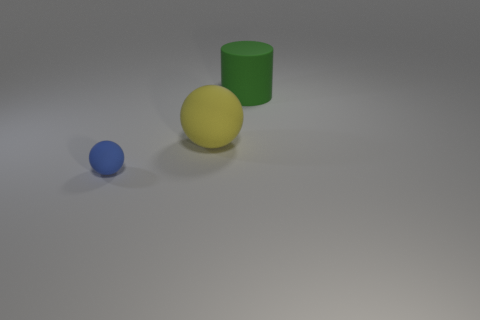Add 1 large green matte things. How many objects exist? 4 Subtract all blue spheres. How many spheres are left? 1 Subtract all red balls. Subtract all green blocks. How many balls are left? 2 Subtract all yellow blocks. How many brown cylinders are left? 0 Subtract all cylinders. Subtract all big rubber things. How many objects are left? 0 Add 2 tiny matte balls. How many tiny matte balls are left? 3 Add 3 green cylinders. How many green cylinders exist? 4 Subtract 0 cyan cylinders. How many objects are left? 3 Subtract all cylinders. How many objects are left? 2 Subtract 1 balls. How many balls are left? 1 